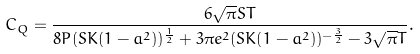Convert formula to latex. <formula><loc_0><loc_0><loc_500><loc_500>C _ { Q } = \frac { 6 \sqrt { \pi } S T } { 8 P ( S K ( 1 - a ^ { 2 } ) ) ^ { \frac { 1 } { 2 } } + 3 \pi e ^ { 2 } ( S K ( 1 - a ^ { 2 } ) ) ^ { - \frac { 3 } { 2 } } - 3 \sqrt { \pi } T } .</formula> 